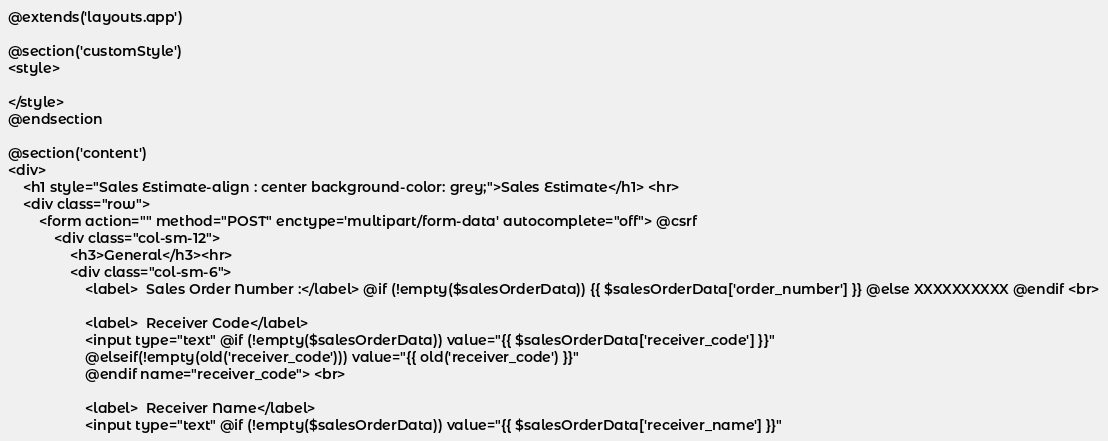Convert code to text. <code><loc_0><loc_0><loc_500><loc_500><_PHP_>@extends('layouts.app')

@section('customStyle') 
<style>
    
</style>
@endsection

@section('content')
<div>
    <h1 style="Sales Estimate-align : center background-color: grey;">Sales Estimate</h1> <hr>
    <div class="row">
        <form action="" method="POST" enctype='multipart/form-data' autocomplete="off"> @csrf
            <div class="col-sm-12">
                <h3>General</h3><hr>
                <div class="col-sm-6">
                    <label>	Sales Order Number :</label> @if (!empty($salesOrderData)) {{ $salesOrderData['order_number'] }} @else XXXXXXXXXX @endif <br>
    
                    <label>	Receiver Code</label>
                    <input type="text" @if (!empty($salesOrderData)) value="{{ $salesOrderData['receiver_code'] }}" 
                    @elseif(!empty(old('receiver_code'))) value="{{ old('receiver_code') }}"
                    @endif name="receiver_code"> <br>
    
                    <label>	Receiver Name</label>
                    <input type="text" @if (!empty($salesOrderData)) value="{{ $salesOrderData['receiver_name'] }}" </code> 